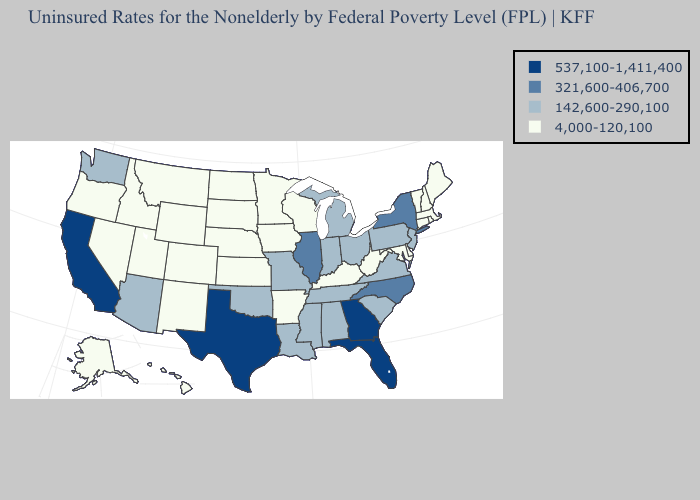Does New Hampshire have the lowest value in the Northeast?
Write a very short answer. Yes. Name the states that have a value in the range 142,600-290,100?
Write a very short answer. Alabama, Arizona, Indiana, Louisiana, Michigan, Mississippi, Missouri, New Jersey, Ohio, Oklahoma, Pennsylvania, South Carolina, Tennessee, Virginia, Washington. Which states have the lowest value in the South?
Answer briefly. Arkansas, Delaware, Kentucky, Maryland, West Virginia. Name the states that have a value in the range 142,600-290,100?
Give a very brief answer. Alabama, Arizona, Indiana, Louisiana, Michigan, Mississippi, Missouri, New Jersey, Ohio, Oklahoma, Pennsylvania, South Carolina, Tennessee, Virginia, Washington. Is the legend a continuous bar?
Write a very short answer. No. Name the states that have a value in the range 4,000-120,100?
Give a very brief answer. Alaska, Arkansas, Colorado, Connecticut, Delaware, Hawaii, Idaho, Iowa, Kansas, Kentucky, Maine, Maryland, Massachusetts, Minnesota, Montana, Nebraska, Nevada, New Hampshire, New Mexico, North Dakota, Oregon, Rhode Island, South Dakota, Utah, Vermont, West Virginia, Wisconsin, Wyoming. What is the highest value in states that border Indiana?
Quick response, please. 321,600-406,700. Which states hav the highest value in the West?
Keep it brief. California. What is the value of Delaware?
Write a very short answer. 4,000-120,100. Name the states that have a value in the range 142,600-290,100?
Give a very brief answer. Alabama, Arizona, Indiana, Louisiana, Michigan, Mississippi, Missouri, New Jersey, Ohio, Oklahoma, Pennsylvania, South Carolina, Tennessee, Virginia, Washington. What is the value of Washington?
Concise answer only. 142,600-290,100. How many symbols are there in the legend?
Keep it brief. 4. What is the value of New Jersey?
Answer briefly. 142,600-290,100. Name the states that have a value in the range 4,000-120,100?
Write a very short answer. Alaska, Arkansas, Colorado, Connecticut, Delaware, Hawaii, Idaho, Iowa, Kansas, Kentucky, Maine, Maryland, Massachusetts, Minnesota, Montana, Nebraska, Nevada, New Hampshire, New Mexico, North Dakota, Oregon, Rhode Island, South Dakota, Utah, Vermont, West Virginia, Wisconsin, Wyoming. What is the value of New Jersey?
Concise answer only. 142,600-290,100. 